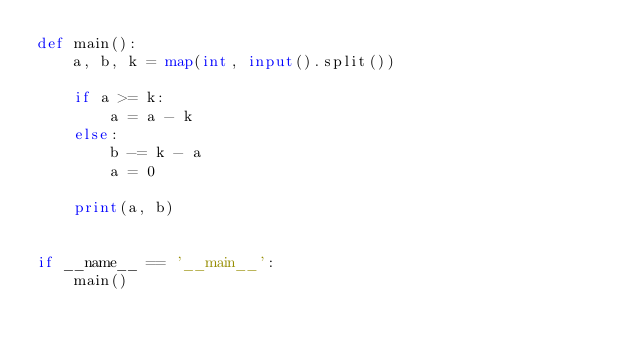<code> <loc_0><loc_0><loc_500><loc_500><_Python_>def main():
    a, b, k = map(int, input().split())

    if a >= k:
        a = a - k
    else:
        b -= k - a
        a = 0

    print(a, b)


if __name__ == '__main__':
    main()
</code> 